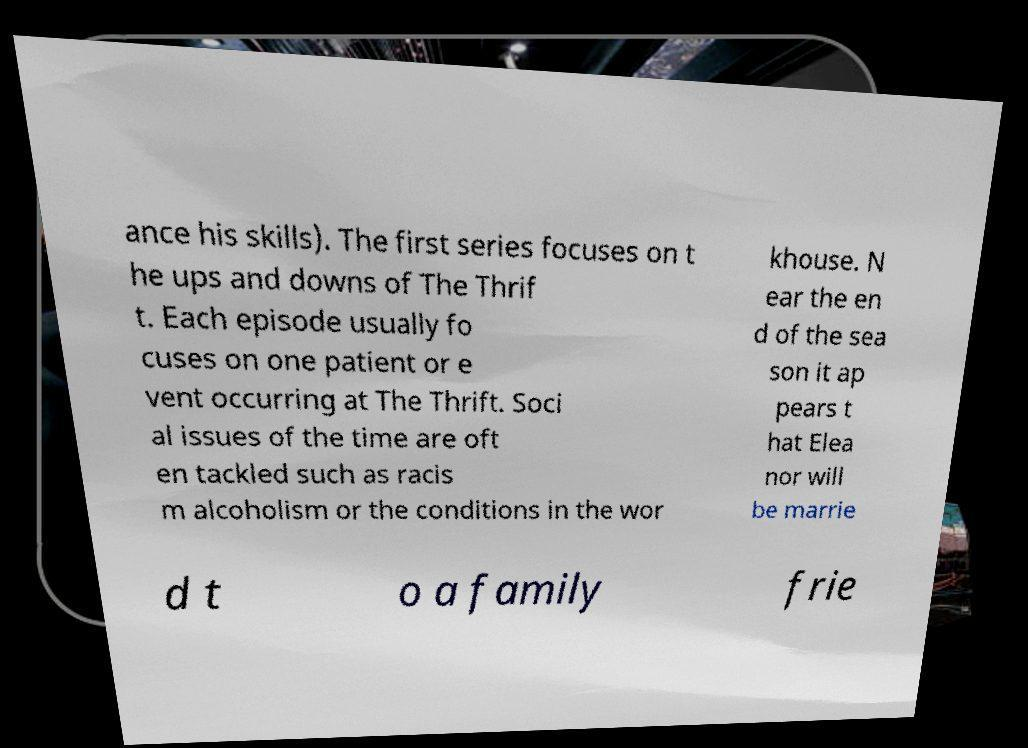There's text embedded in this image that I need extracted. Can you transcribe it verbatim? ance his skills). The first series focuses on t he ups and downs of The Thrif t. Each episode usually fo cuses on one patient or e vent occurring at The Thrift. Soci al issues of the time are oft en tackled such as racis m alcoholism or the conditions in the wor khouse. N ear the en d of the sea son it ap pears t hat Elea nor will be marrie d t o a family frie 